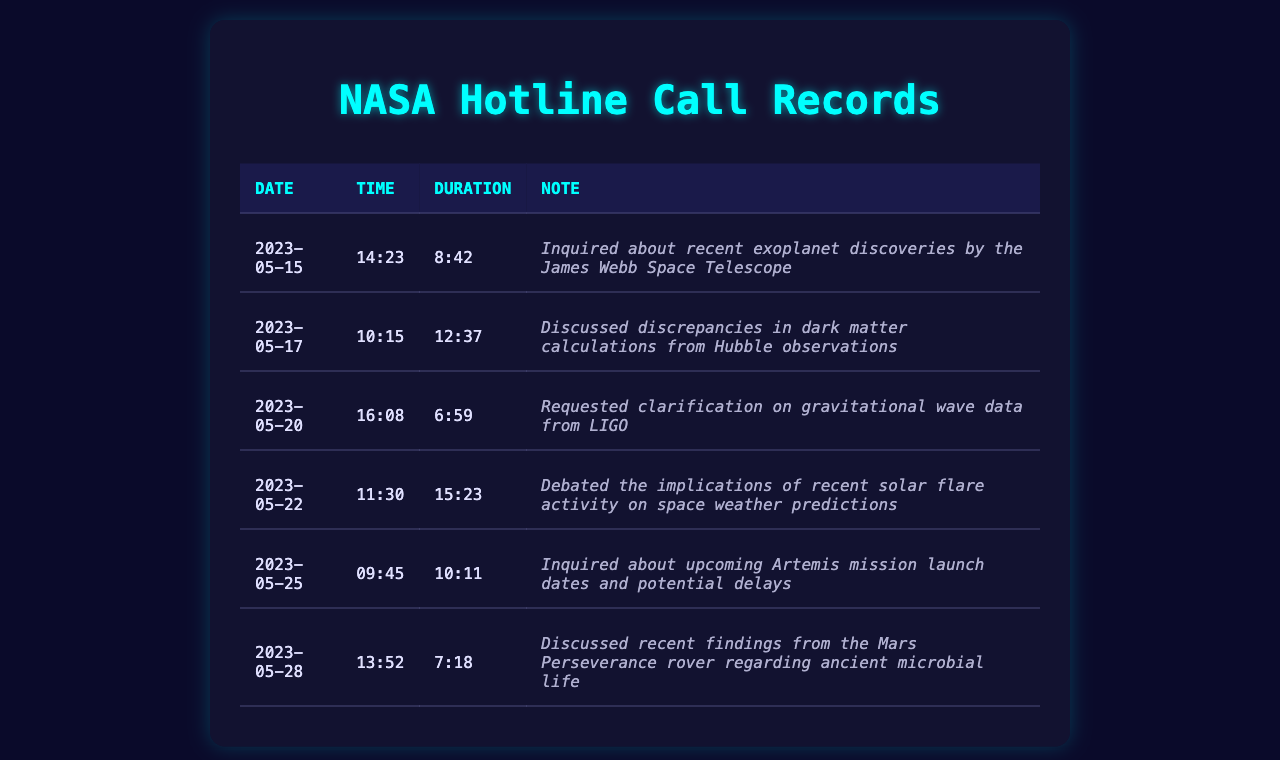What was the duration of the call on May 22? It is found in the table under the "Duration" column corresponding to the date May 22, which is 15:23.
Answer: 15:23 How many calls were made in total? By counting the number of rows in the table, we find there are six entries, each representing a call.
Answer: 6 What was discussed during the call on May 20? The content of the call is indicated in the "Note" column for that date, which mentions gravitational wave data from LIGO.
Answer: Clarification on gravitational wave data from LIGO Which call had the longest duration? By comparing the durations in the "Duration" column, the longest duration is noted to be 15:23 on May 22.
Answer: 15:23 On what date was the call regarding Mars Perseverance rover findings made? The date is specified in the "Date" column associated with the note about the Mars Perseverance rover, which is May 28.
Answer: May 28 How many calls involved discussions about recent findings or discoveries? By reviewing the "Note" column, we identify three calls that address recent findings: exoplanets, solar flares, and Mars rover findings.
Answer: 3 